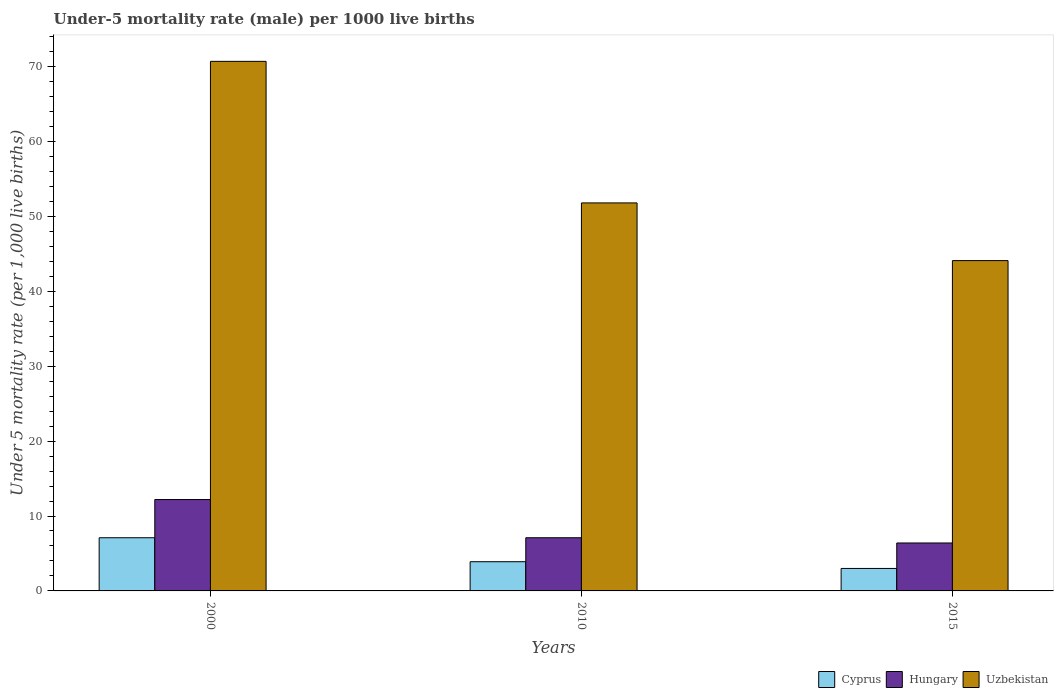How many groups of bars are there?
Provide a succinct answer. 3. How many bars are there on the 2nd tick from the right?
Provide a succinct answer. 3. What is the label of the 1st group of bars from the left?
Give a very brief answer. 2000. What is the under-five mortality rate in Cyprus in 2000?
Provide a short and direct response. 7.1. Across all years, what is the minimum under-five mortality rate in Cyprus?
Your answer should be very brief. 3. In which year was the under-five mortality rate in Uzbekistan minimum?
Make the answer very short. 2015. What is the total under-five mortality rate in Uzbekistan in the graph?
Your response must be concise. 166.6. What is the difference between the under-five mortality rate in Cyprus in 2000 and that in 2010?
Offer a terse response. 3.2. What is the difference between the under-five mortality rate in Hungary in 2000 and the under-five mortality rate in Cyprus in 2015?
Offer a terse response. 9.2. What is the average under-five mortality rate in Cyprus per year?
Your response must be concise. 4.67. In the year 2010, what is the difference between the under-five mortality rate in Cyprus and under-five mortality rate in Uzbekistan?
Your answer should be compact. -47.9. What is the ratio of the under-five mortality rate in Cyprus in 2010 to that in 2015?
Your response must be concise. 1.3. Is the under-five mortality rate in Uzbekistan in 2000 less than that in 2010?
Ensure brevity in your answer.  No. What is the difference between the highest and the lowest under-five mortality rate in Cyprus?
Give a very brief answer. 4.1. Is the sum of the under-five mortality rate in Hungary in 2010 and 2015 greater than the maximum under-five mortality rate in Cyprus across all years?
Offer a very short reply. Yes. What does the 3rd bar from the left in 2015 represents?
Offer a terse response. Uzbekistan. What does the 3rd bar from the right in 2010 represents?
Offer a very short reply. Cyprus. Is it the case that in every year, the sum of the under-five mortality rate in Cyprus and under-five mortality rate in Uzbekistan is greater than the under-five mortality rate in Hungary?
Keep it short and to the point. Yes. How many bars are there?
Ensure brevity in your answer.  9. Are all the bars in the graph horizontal?
Your response must be concise. No. Are the values on the major ticks of Y-axis written in scientific E-notation?
Offer a terse response. No. Does the graph contain any zero values?
Your answer should be very brief. No. Does the graph contain grids?
Your answer should be very brief. No. What is the title of the graph?
Provide a succinct answer. Under-5 mortality rate (male) per 1000 live births. Does "Cayman Islands" appear as one of the legend labels in the graph?
Your answer should be compact. No. What is the label or title of the X-axis?
Give a very brief answer. Years. What is the label or title of the Y-axis?
Provide a short and direct response. Under 5 mortality rate (per 1,0 live births). What is the Under 5 mortality rate (per 1,000 live births) of Uzbekistan in 2000?
Offer a terse response. 70.7. What is the Under 5 mortality rate (per 1,000 live births) of Uzbekistan in 2010?
Provide a succinct answer. 51.8. What is the Under 5 mortality rate (per 1,000 live births) of Cyprus in 2015?
Give a very brief answer. 3. What is the Under 5 mortality rate (per 1,000 live births) of Uzbekistan in 2015?
Offer a terse response. 44.1. Across all years, what is the maximum Under 5 mortality rate (per 1,000 live births) in Cyprus?
Give a very brief answer. 7.1. Across all years, what is the maximum Under 5 mortality rate (per 1,000 live births) in Uzbekistan?
Offer a terse response. 70.7. Across all years, what is the minimum Under 5 mortality rate (per 1,000 live births) of Hungary?
Provide a short and direct response. 6.4. Across all years, what is the minimum Under 5 mortality rate (per 1,000 live births) in Uzbekistan?
Ensure brevity in your answer.  44.1. What is the total Under 5 mortality rate (per 1,000 live births) in Hungary in the graph?
Provide a short and direct response. 25.7. What is the total Under 5 mortality rate (per 1,000 live births) of Uzbekistan in the graph?
Ensure brevity in your answer.  166.6. What is the difference between the Under 5 mortality rate (per 1,000 live births) of Cyprus in 2000 and that in 2010?
Your answer should be very brief. 3.2. What is the difference between the Under 5 mortality rate (per 1,000 live births) of Hungary in 2000 and that in 2010?
Offer a terse response. 5.1. What is the difference between the Under 5 mortality rate (per 1,000 live births) of Cyprus in 2000 and that in 2015?
Your response must be concise. 4.1. What is the difference between the Under 5 mortality rate (per 1,000 live births) in Uzbekistan in 2000 and that in 2015?
Keep it short and to the point. 26.6. What is the difference between the Under 5 mortality rate (per 1,000 live births) of Hungary in 2010 and that in 2015?
Offer a terse response. 0.7. What is the difference between the Under 5 mortality rate (per 1,000 live births) in Cyprus in 2000 and the Under 5 mortality rate (per 1,000 live births) in Uzbekistan in 2010?
Offer a very short reply. -44.7. What is the difference between the Under 5 mortality rate (per 1,000 live births) in Hungary in 2000 and the Under 5 mortality rate (per 1,000 live births) in Uzbekistan in 2010?
Provide a short and direct response. -39.6. What is the difference between the Under 5 mortality rate (per 1,000 live births) in Cyprus in 2000 and the Under 5 mortality rate (per 1,000 live births) in Hungary in 2015?
Give a very brief answer. 0.7. What is the difference between the Under 5 mortality rate (per 1,000 live births) in Cyprus in 2000 and the Under 5 mortality rate (per 1,000 live births) in Uzbekistan in 2015?
Make the answer very short. -37. What is the difference between the Under 5 mortality rate (per 1,000 live births) of Hungary in 2000 and the Under 5 mortality rate (per 1,000 live births) of Uzbekistan in 2015?
Ensure brevity in your answer.  -31.9. What is the difference between the Under 5 mortality rate (per 1,000 live births) of Cyprus in 2010 and the Under 5 mortality rate (per 1,000 live births) of Uzbekistan in 2015?
Your answer should be very brief. -40.2. What is the difference between the Under 5 mortality rate (per 1,000 live births) of Hungary in 2010 and the Under 5 mortality rate (per 1,000 live births) of Uzbekistan in 2015?
Your answer should be compact. -37. What is the average Under 5 mortality rate (per 1,000 live births) in Cyprus per year?
Offer a very short reply. 4.67. What is the average Under 5 mortality rate (per 1,000 live births) in Hungary per year?
Make the answer very short. 8.57. What is the average Under 5 mortality rate (per 1,000 live births) of Uzbekistan per year?
Your response must be concise. 55.53. In the year 2000, what is the difference between the Under 5 mortality rate (per 1,000 live births) of Cyprus and Under 5 mortality rate (per 1,000 live births) of Hungary?
Keep it short and to the point. -5.1. In the year 2000, what is the difference between the Under 5 mortality rate (per 1,000 live births) of Cyprus and Under 5 mortality rate (per 1,000 live births) of Uzbekistan?
Your answer should be compact. -63.6. In the year 2000, what is the difference between the Under 5 mortality rate (per 1,000 live births) of Hungary and Under 5 mortality rate (per 1,000 live births) of Uzbekistan?
Your response must be concise. -58.5. In the year 2010, what is the difference between the Under 5 mortality rate (per 1,000 live births) in Cyprus and Under 5 mortality rate (per 1,000 live births) in Uzbekistan?
Your response must be concise. -47.9. In the year 2010, what is the difference between the Under 5 mortality rate (per 1,000 live births) in Hungary and Under 5 mortality rate (per 1,000 live births) in Uzbekistan?
Your answer should be compact. -44.7. In the year 2015, what is the difference between the Under 5 mortality rate (per 1,000 live births) in Cyprus and Under 5 mortality rate (per 1,000 live births) in Uzbekistan?
Provide a short and direct response. -41.1. In the year 2015, what is the difference between the Under 5 mortality rate (per 1,000 live births) of Hungary and Under 5 mortality rate (per 1,000 live births) of Uzbekistan?
Your answer should be compact. -37.7. What is the ratio of the Under 5 mortality rate (per 1,000 live births) in Cyprus in 2000 to that in 2010?
Provide a short and direct response. 1.82. What is the ratio of the Under 5 mortality rate (per 1,000 live births) of Hungary in 2000 to that in 2010?
Make the answer very short. 1.72. What is the ratio of the Under 5 mortality rate (per 1,000 live births) in Uzbekistan in 2000 to that in 2010?
Your answer should be compact. 1.36. What is the ratio of the Under 5 mortality rate (per 1,000 live births) in Cyprus in 2000 to that in 2015?
Offer a terse response. 2.37. What is the ratio of the Under 5 mortality rate (per 1,000 live births) in Hungary in 2000 to that in 2015?
Ensure brevity in your answer.  1.91. What is the ratio of the Under 5 mortality rate (per 1,000 live births) of Uzbekistan in 2000 to that in 2015?
Ensure brevity in your answer.  1.6. What is the ratio of the Under 5 mortality rate (per 1,000 live births) in Hungary in 2010 to that in 2015?
Your response must be concise. 1.11. What is the ratio of the Under 5 mortality rate (per 1,000 live births) in Uzbekistan in 2010 to that in 2015?
Your response must be concise. 1.17. What is the difference between the highest and the second highest Under 5 mortality rate (per 1,000 live births) in Cyprus?
Ensure brevity in your answer.  3.2. What is the difference between the highest and the second highest Under 5 mortality rate (per 1,000 live births) in Hungary?
Provide a short and direct response. 5.1. What is the difference between the highest and the second highest Under 5 mortality rate (per 1,000 live births) in Uzbekistan?
Make the answer very short. 18.9. What is the difference between the highest and the lowest Under 5 mortality rate (per 1,000 live births) of Hungary?
Keep it short and to the point. 5.8. What is the difference between the highest and the lowest Under 5 mortality rate (per 1,000 live births) in Uzbekistan?
Provide a succinct answer. 26.6. 